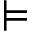<formula> <loc_0><loc_0><loc_500><loc_500>\vDash</formula> 